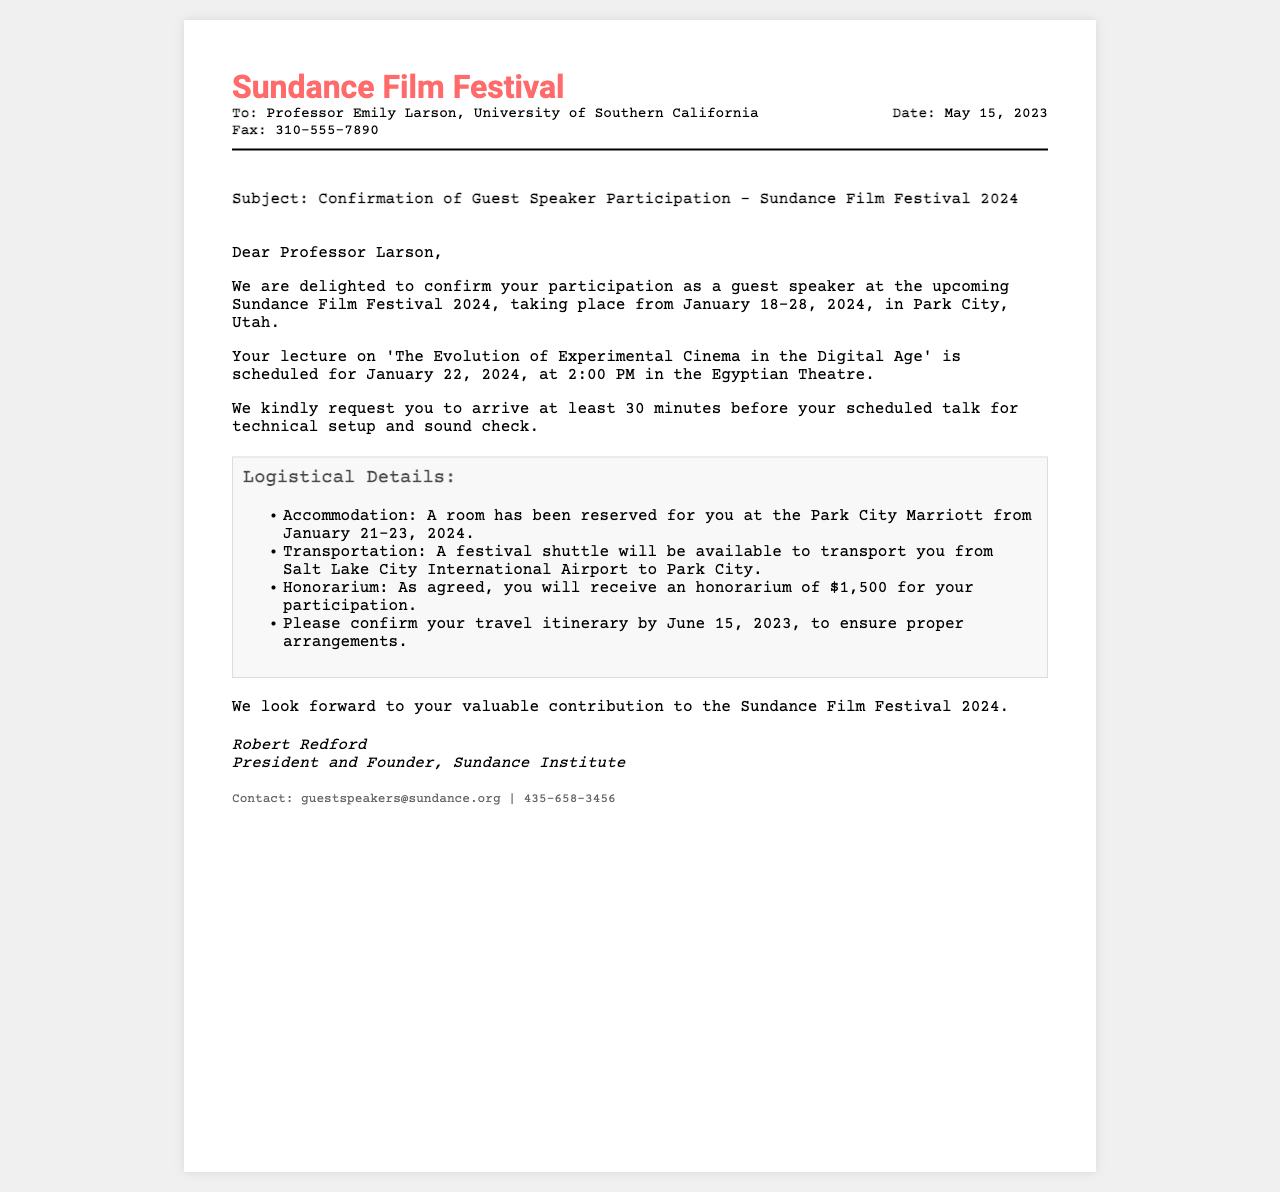What is the name of the film festival? The name of the festival is specified in the document header.
Answer: Sundance Film Festival Who is the guest speaker? The guest speaker is mentioned in the opening address of the fax.
Answer: Professor Emily Larson What date is the lecture scheduled for? The lecture date is provided in the content section of the fax.
Answer: January 22, 2024 What time should the speaker arrive for the talk? The arrival time is referenced in the content section prior to the lecture details.
Answer: 30 minutes What is the honorarium amount? The honorarium is cited in the logistical details of the fax.
Answer: $1,500 What is the title of the lecture? The title is clearly stated in the content section of the fax.
Answer: The Evolution of Experimental Cinema in the Digital Age What is the location of the event? The location is detailed in the content section where the event is taking place.
Answer: Egyptian Theatre By when should the travel itinerary be confirmed? The confirmation date for the travel itinerary is specified in the logistical details.
Answer: June 15, 2023 What type of accommodation is provided? The type of accommodation is described in the logistical details section.
Answer: A room at Park City Marriott 